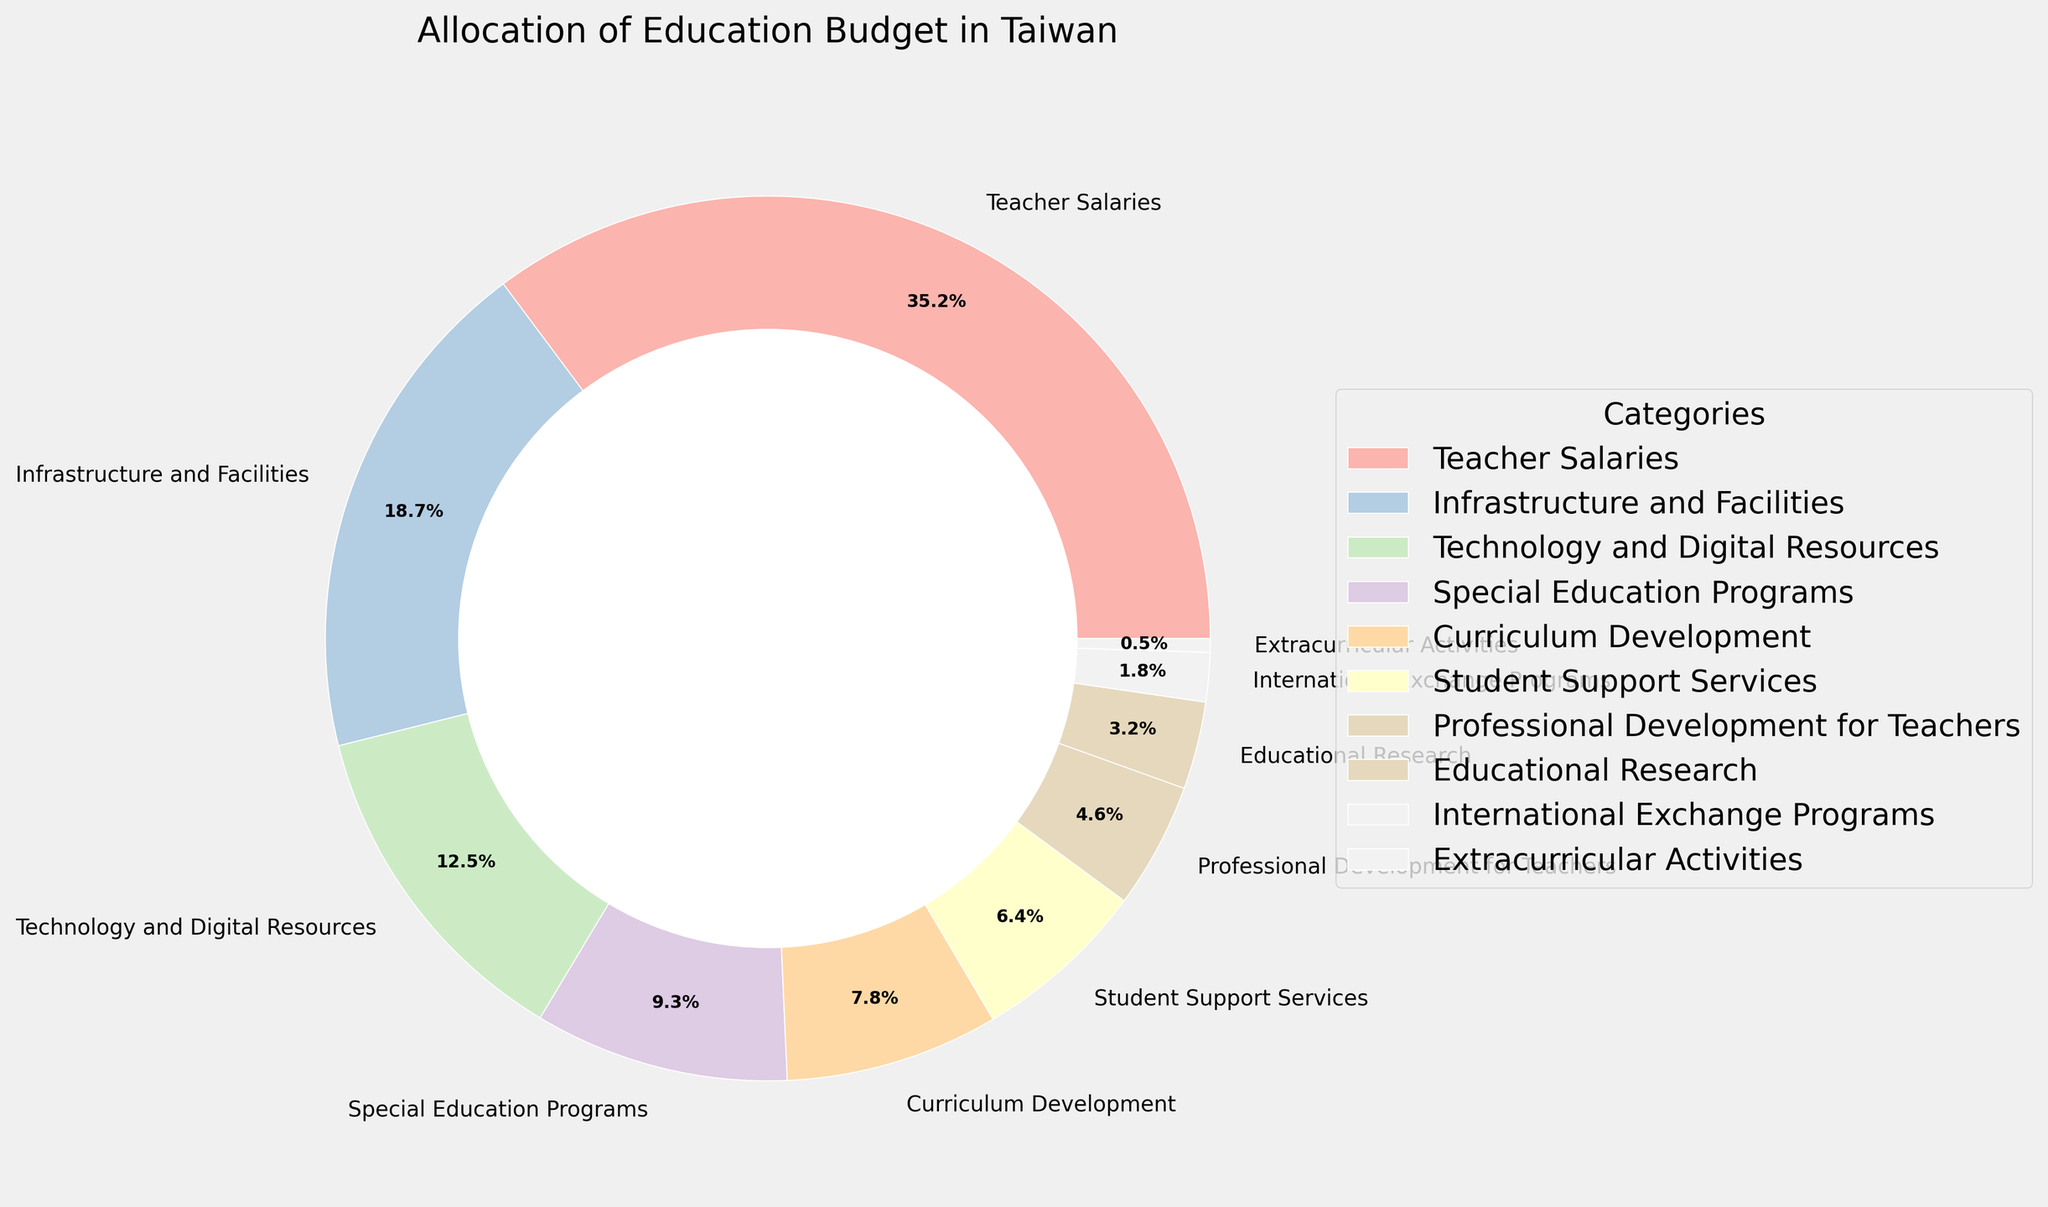What are the two largest budget categories in Taiwan's education budget allocation? First, identify which two categories have the highest percentages in the pie chart. Teacher Salaries has 35.2%, and Infrastructure and Facilities has 18.7%, which are the two largest categories.
Answer: Teacher Salaries and Infrastructure and Facilities How much more is allocated to Teacher Salaries compared to Technology and Digital Resources? Identify the percentages for Teacher Salaries and Technology and Digital Resources. Teacher Salaries are at 35.2% and Technology and Digital Resources are at 12.5%. Subtract the smaller percentage from the larger one: 35.2% - 12.5% = 22.7%.
Answer: 22.7% What is the combined percentage of Curriculum Development and Student Support Services? Identify the percentages for Curriculum Development and Student Support Services. Curriculum Development is at 7.8%, and Student Support Services are at 6.4%. Add the two percentages together: 7.8% + 6.4% = 14.2%.
Answer: 14.2% Which category is allocated the least amount of the budget? Look for the category with the smallest percentage in the pie chart. Extracurricular Activities have the smallest percentage at 0.5%.
Answer: Extracurricular Activities What is the difference in budget allocation between Special Education Programs and Professional Development for Teachers? Identify the percentages for Special Education Programs and Professional Development for Teachers. Special Education Programs are at 9.3%, and Professional Development for Teachers is at 4.6%. Subtract the smaller percentage from the larger one: 9.3% - 4.6% = 4.7%.
Answer: 4.7% How does the budget allocation for Technology and Digital Resources compare to Infrastructure and Facilities? Identify the percentages for Technology and Digital Resources and Infrastructure and Facilities. Technology and Digital Resources are at 12.5%, whereas Infrastructure and Facilities are at 18.7%. Compare the two percentages: Infrastructure and Facilities (18.7%) > Technology and Digital Resources (12.5%).
Answer: Infrastructure and Facilities have a higher budget allocation What is the total percentage allocated to categories related to teaching staff, including Teacher Salaries and Professional Development for Teachers? Identify the percentages for Teacher Salaries and Professional Development for Teachers. Teacher Salaries are at 35.2%, and Professional Development for Teachers is at 4.6%. Add the two percentages together: 35.2% + 4.6% = 39.8%.
Answer: 39.8% What is the combined budget allocation for categories directly benefiting students, including Special Education Programs, Student Support Services, International Exchange Programs, and Extracurricular Activities? Identify the percentages for Special Education Programs, Student Support Services, International Exchange Programs, and Extracurricular Activities. They are 9.3%, 6.4%, 1.8%, and 0.5%, respectively. Add the four percentages together: 9.3% + 6.4% + 1.8% + 0.5% = 18%.
Answer: 18% How much less budget is allocated to Educational Research compared to Infrastructure and Facilities? Identify the percentages for Educational Research and Infrastructure and Facilities. Educational Research is at 3.2%, and Infrastructure and Facilities are at 18.7%. Subtract the smaller percentage from the larger one: 18.7% - 3.2% = 15.5%.
Answer: 15.5% 